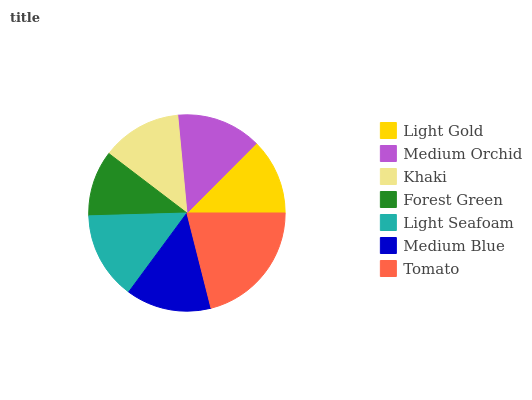Is Forest Green the minimum?
Answer yes or no. Yes. Is Tomato the maximum?
Answer yes or no. Yes. Is Medium Orchid the minimum?
Answer yes or no. No. Is Medium Orchid the maximum?
Answer yes or no. No. Is Medium Orchid greater than Light Gold?
Answer yes or no. Yes. Is Light Gold less than Medium Orchid?
Answer yes or no. Yes. Is Light Gold greater than Medium Orchid?
Answer yes or no. No. Is Medium Orchid less than Light Gold?
Answer yes or no. No. Is Medium Orchid the high median?
Answer yes or no. Yes. Is Medium Orchid the low median?
Answer yes or no. Yes. Is Tomato the high median?
Answer yes or no. No. Is Khaki the low median?
Answer yes or no. No. 